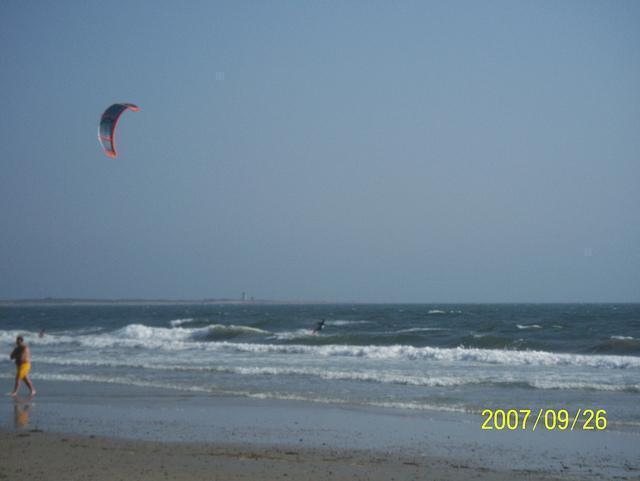How much older is this man now?
Indicate the correct response by choosing from the four available options to answer the question.
Options: 10 years, 22 years, 14 years, 30 years. 14 years. 